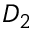<formula> <loc_0><loc_0><loc_500><loc_500>D _ { 2 }</formula> 